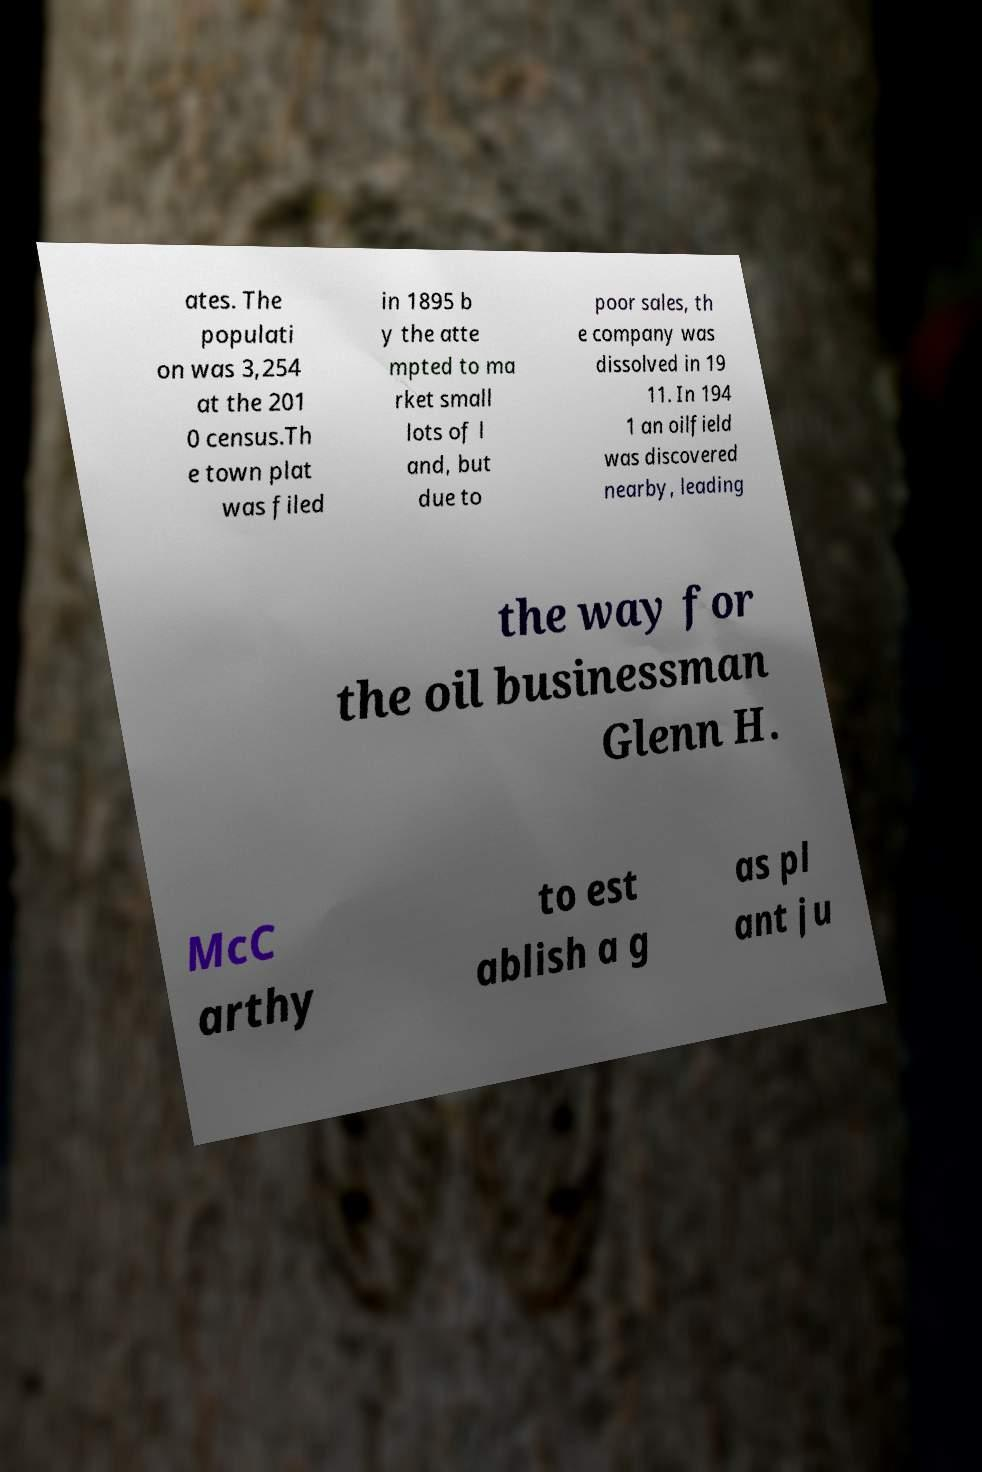Could you extract and type out the text from this image? ates. The populati on was 3,254 at the 201 0 census.Th e town plat was filed in 1895 b y the atte mpted to ma rket small lots of l and, but due to poor sales, th e company was dissolved in 19 11. In 194 1 an oilfield was discovered nearby, leading the way for the oil businessman Glenn H. McC arthy to est ablish a g as pl ant ju 